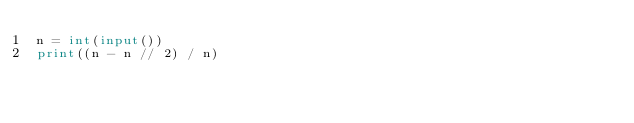Convert code to text. <code><loc_0><loc_0><loc_500><loc_500><_Python_>n = int(input())
print((n - n // 2) / n)</code> 